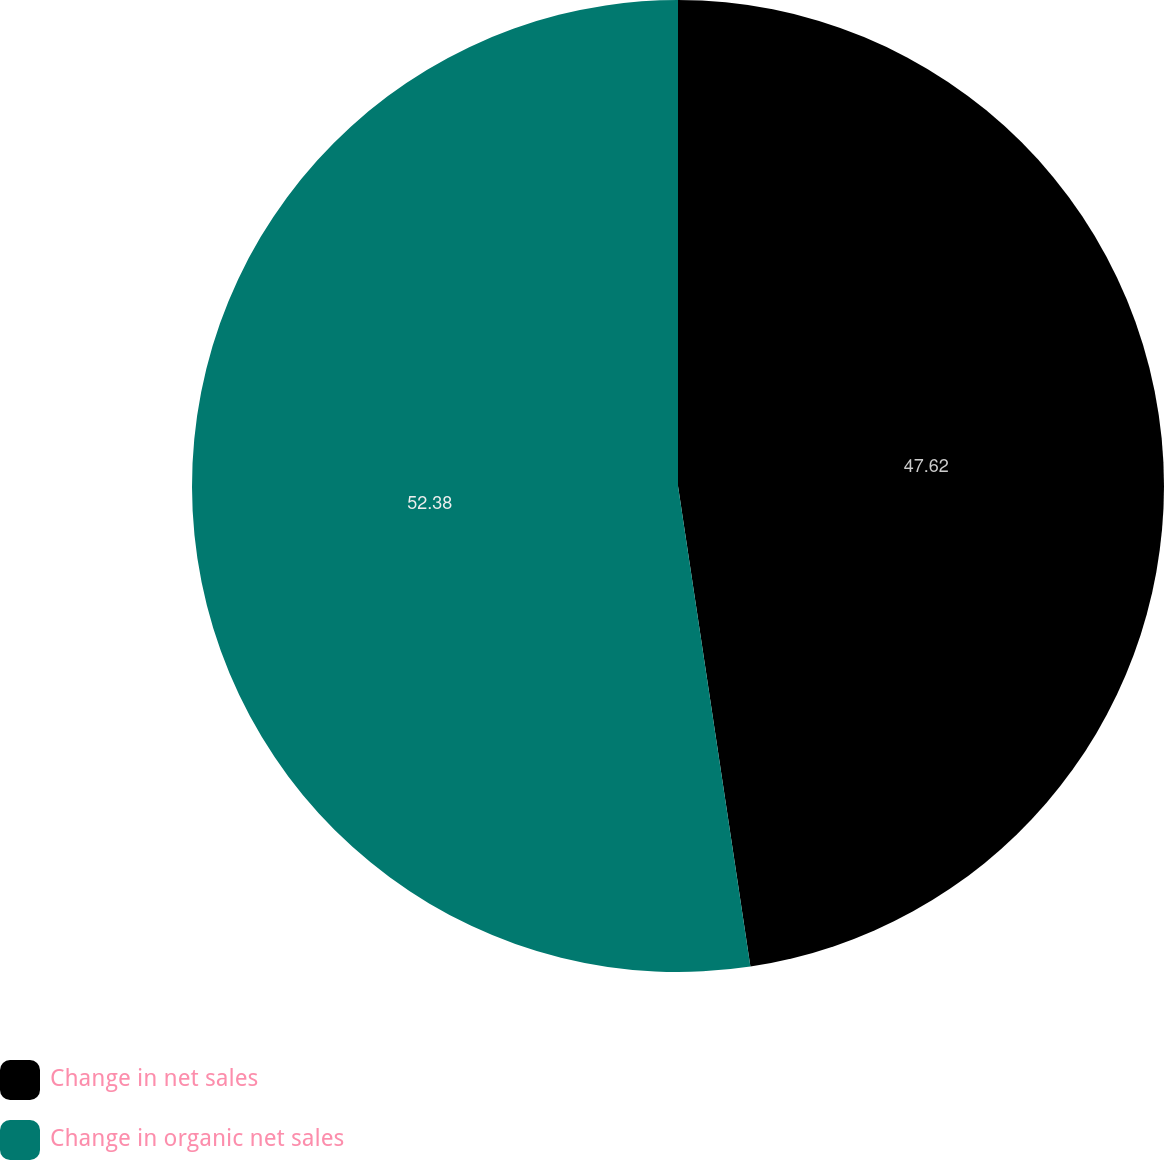Convert chart to OTSL. <chart><loc_0><loc_0><loc_500><loc_500><pie_chart><fcel>Change in net sales<fcel>Change in organic net sales<nl><fcel>47.62%<fcel>52.38%<nl></chart> 